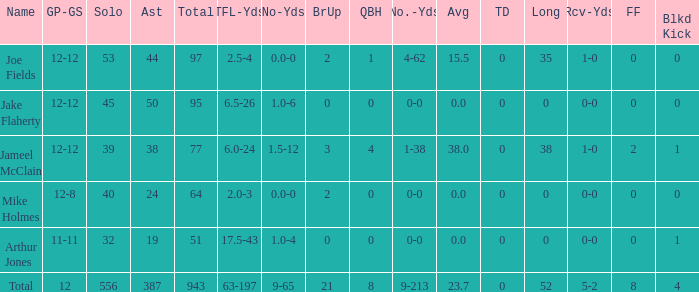What is the distance in yards for the player with tfl-yds of 4-62. 